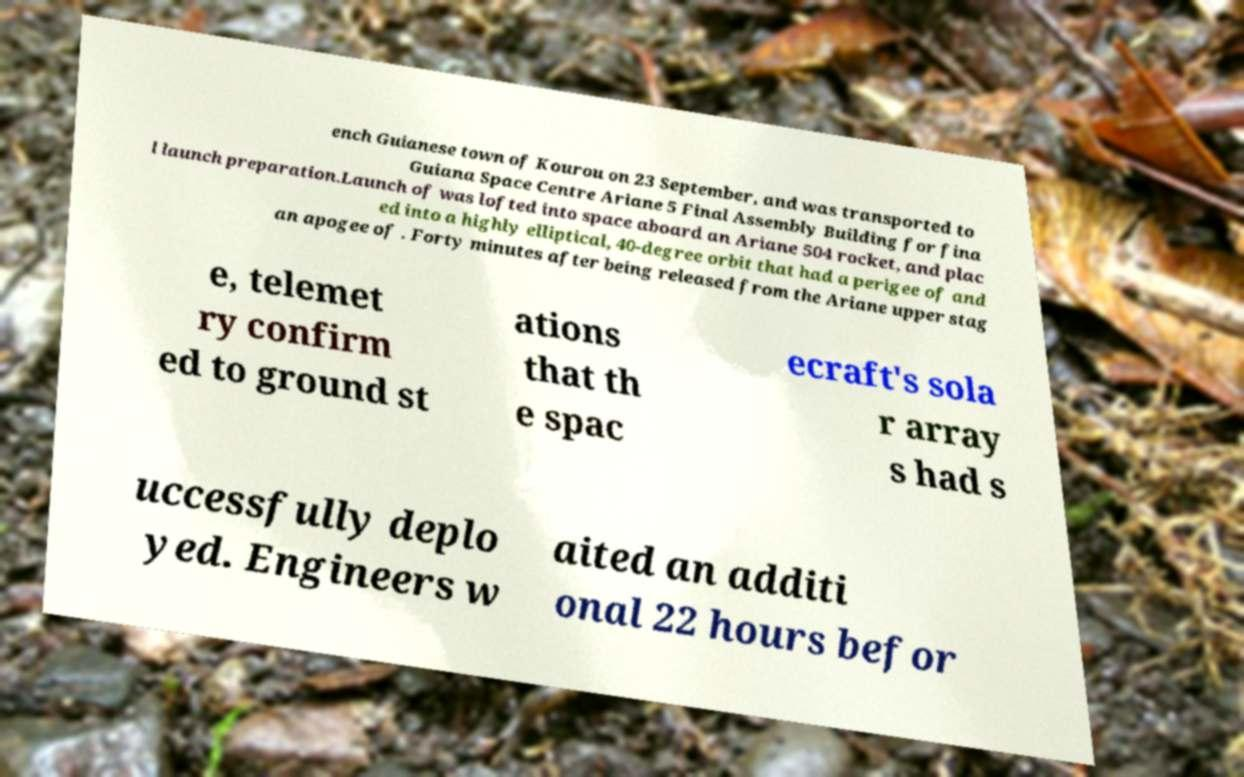Please identify and transcribe the text found in this image. ench Guianese town of Kourou on 23 September, and was transported to Guiana Space Centre Ariane 5 Final Assembly Building for fina l launch preparation.Launch of was lofted into space aboard an Ariane 504 rocket, and plac ed into a highly elliptical, 40-degree orbit that had a perigee of and an apogee of . Forty minutes after being released from the Ariane upper stag e, telemet ry confirm ed to ground st ations that th e spac ecraft's sola r array s had s uccessfully deplo yed. Engineers w aited an additi onal 22 hours befor 